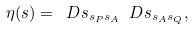<formula> <loc_0><loc_0><loc_500><loc_500>\eta ( s ) = \ D s _ { s _ { P } s _ { A } } \ D s _ { s _ { A } s _ { Q } } ,</formula> 